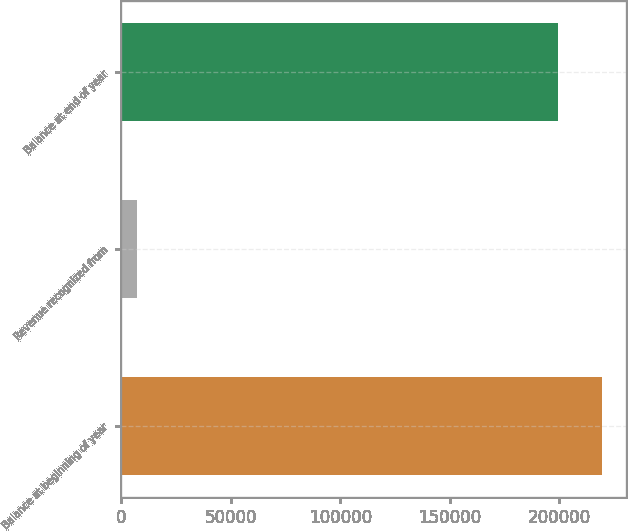Convert chart. <chart><loc_0><loc_0><loc_500><loc_500><bar_chart><fcel>Balance at beginning of year<fcel>Revenue recognized from<fcel>Balance at end of year<nl><fcel>219512<fcel>6912<fcel>199556<nl></chart> 